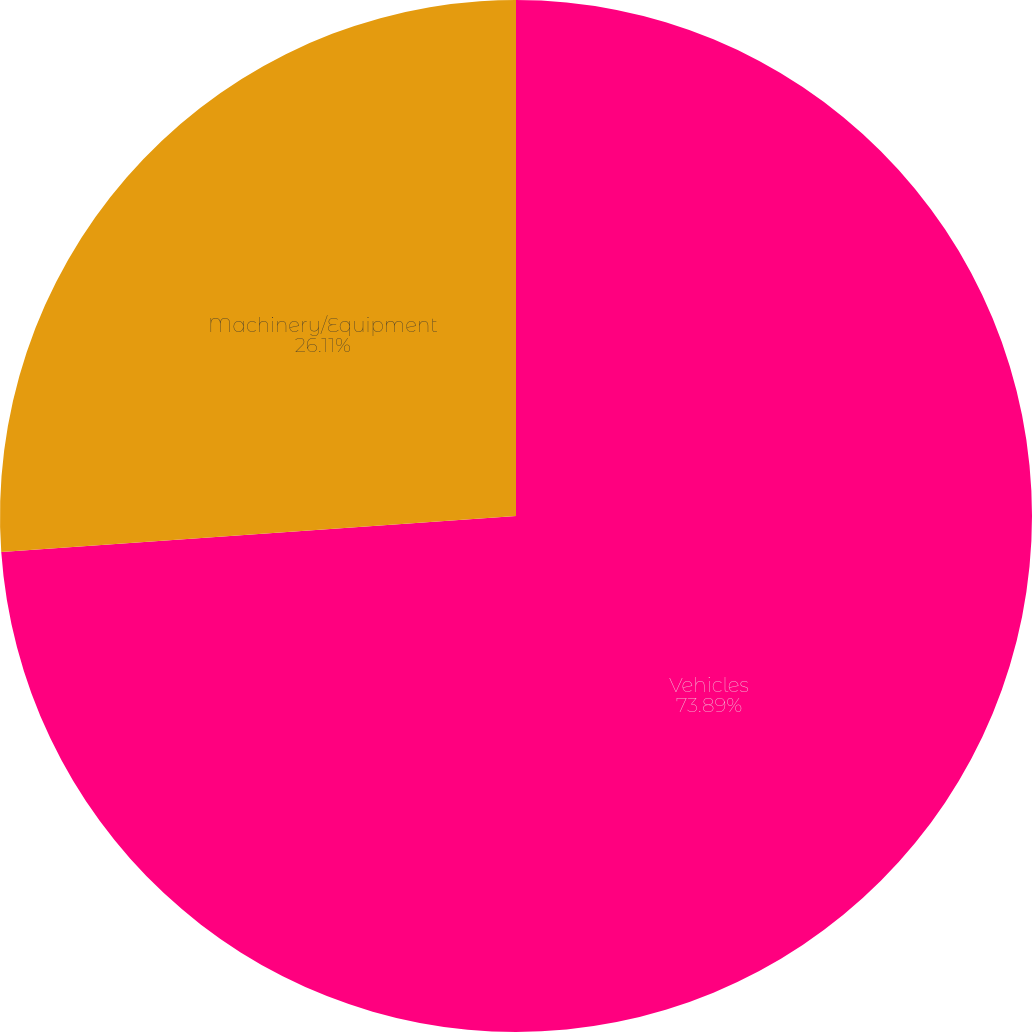Convert chart to OTSL. <chart><loc_0><loc_0><loc_500><loc_500><pie_chart><fcel>Vehicles<fcel>Machinery/Equipment<nl><fcel>73.89%<fcel>26.11%<nl></chart> 